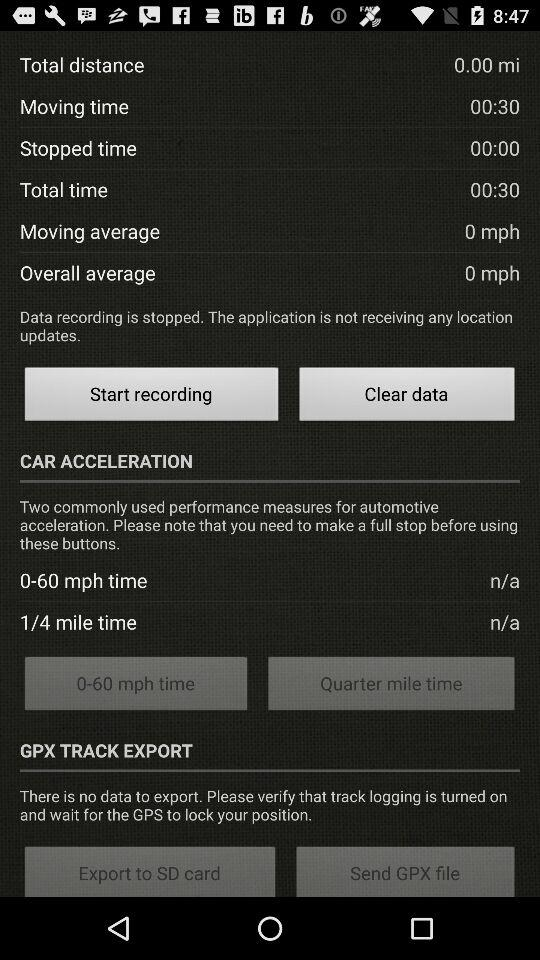How much longer is the moving time than the stopped time?
Answer the question using a single word or phrase. 00:30 